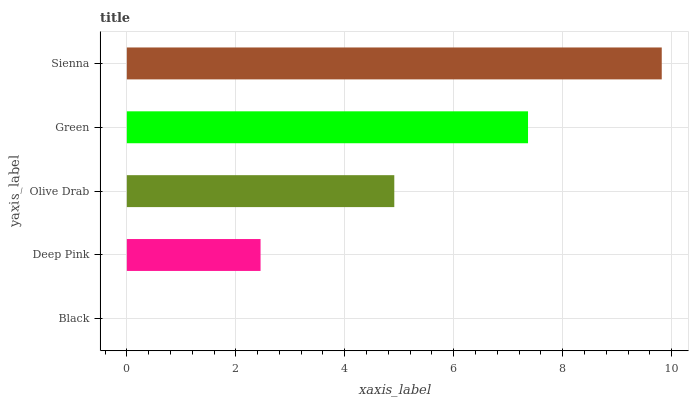Is Black the minimum?
Answer yes or no. Yes. Is Sienna the maximum?
Answer yes or no. Yes. Is Deep Pink the minimum?
Answer yes or no. No. Is Deep Pink the maximum?
Answer yes or no. No. Is Deep Pink greater than Black?
Answer yes or no. Yes. Is Black less than Deep Pink?
Answer yes or no. Yes. Is Black greater than Deep Pink?
Answer yes or no. No. Is Deep Pink less than Black?
Answer yes or no. No. Is Olive Drab the high median?
Answer yes or no. Yes. Is Olive Drab the low median?
Answer yes or no. Yes. Is Sienna the high median?
Answer yes or no. No. Is Green the low median?
Answer yes or no. No. 